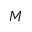<formula> <loc_0><loc_0><loc_500><loc_500>M</formula> 